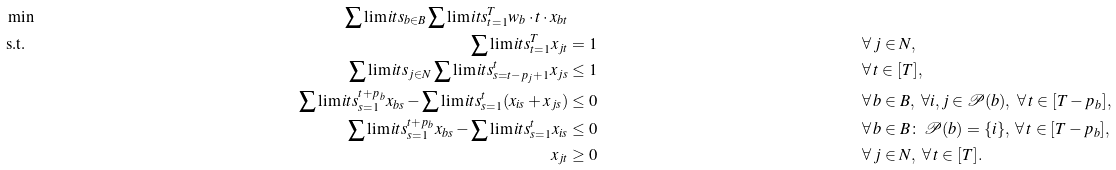<formula> <loc_0><loc_0><loc_500><loc_500>& \min & \sum \lim i t s _ { b \in B } \sum \lim i t s _ { t = 1 } ^ { T } w _ { b } \cdot t \cdot x _ { b t } \\ & \text {s.t.} & \sum \lim i t s _ { t = 1 } ^ { T } x _ { j t } & = 1 & \forall & \, j \in N , \\ & & \sum \lim i t s _ { j \in N } \sum \lim i t s _ { s = t - p _ { j } + 1 } ^ { t } x _ { j s } & \leq 1 & \forall & \, t \in [ T ] , \\ & & \sum \lim i t s _ { s = 1 } ^ { t + p _ { b } } x _ { b s } - \sum \lim i t s _ { s = 1 } ^ { t } ( x _ { i s } + x _ { j s } ) & \leq 0 & \forall & \, b \in B , \ \forall i , j \in \mathcal { P } ( b ) , \ \forall \, t \in [ T - p _ { b } ] , \\ & & \sum \lim i t s _ { s = 1 } ^ { t + p _ { b } } x _ { b s } - \sum \lim i t s _ { s = 1 } ^ { t } x _ { i s } & \leq 0 & \forall & \, b \in B \colon \, \mathcal { P } ( b ) = \{ i \} , \ \forall \, t \in [ T - p _ { b } ] , \\ & & x _ { j t } & \geq 0 & \forall & \, j \in N , \ \forall \, t \in [ T ] .</formula> 